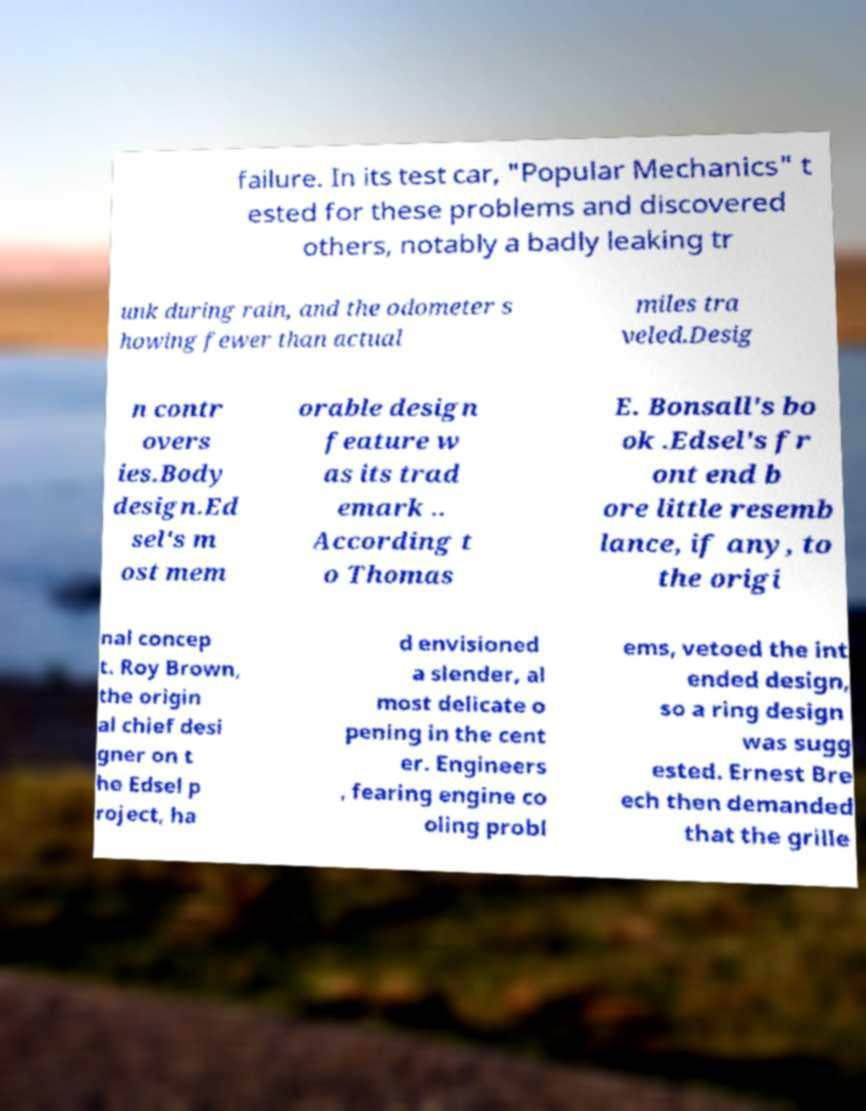Could you assist in decoding the text presented in this image and type it out clearly? failure. In its test car, "Popular Mechanics" t ested for these problems and discovered others, notably a badly leaking tr unk during rain, and the odometer s howing fewer than actual miles tra veled.Desig n contr overs ies.Body design.Ed sel's m ost mem orable design feature w as its trad emark .. According t o Thomas E. Bonsall's bo ok .Edsel's fr ont end b ore little resemb lance, if any, to the origi nal concep t. Roy Brown, the origin al chief desi gner on t he Edsel p roject, ha d envisioned a slender, al most delicate o pening in the cent er. Engineers , fearing engine co oling probl ems, vetoed the int ended design, so a ring design was sugg ested. Ernest Bre ech then demanded that the grille 